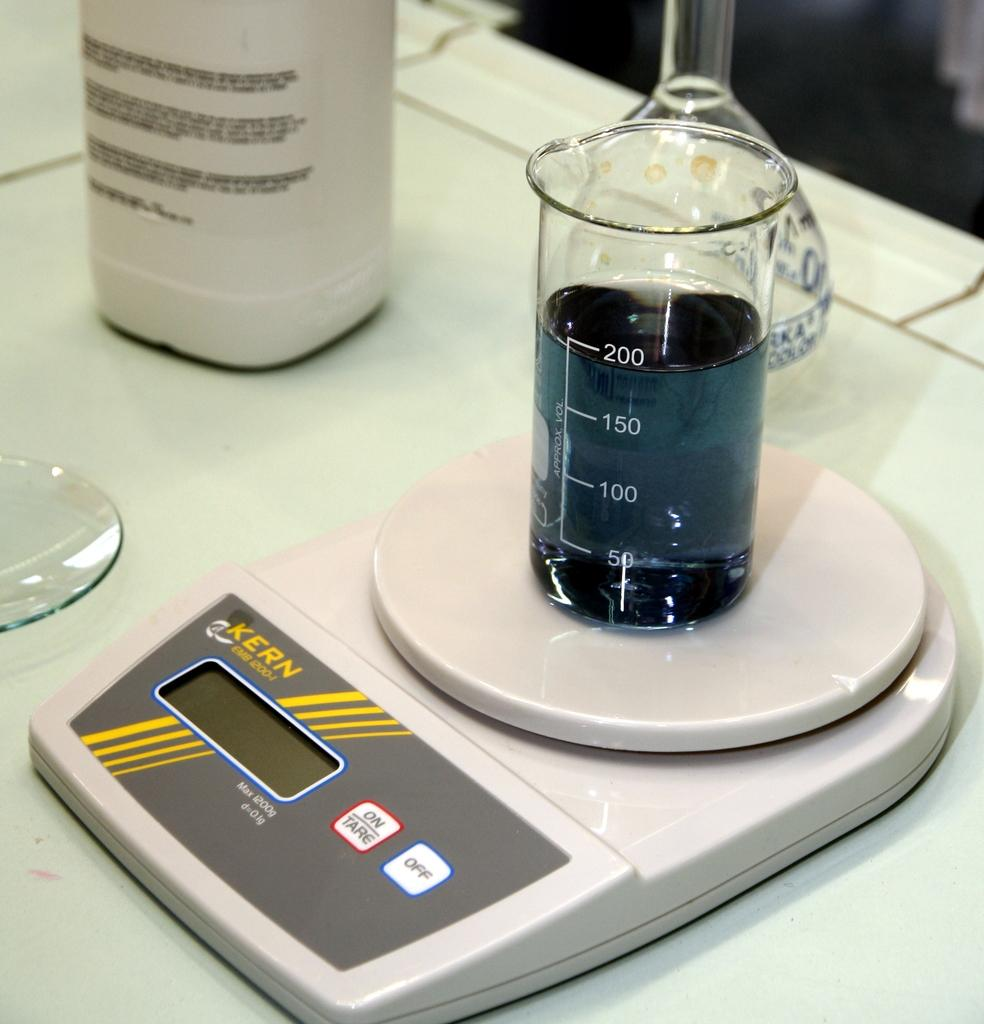<image>
Share a concise interpretation of the image provided. a Kern scale weighing a beaker of blue liquid filled to the 200 mark 